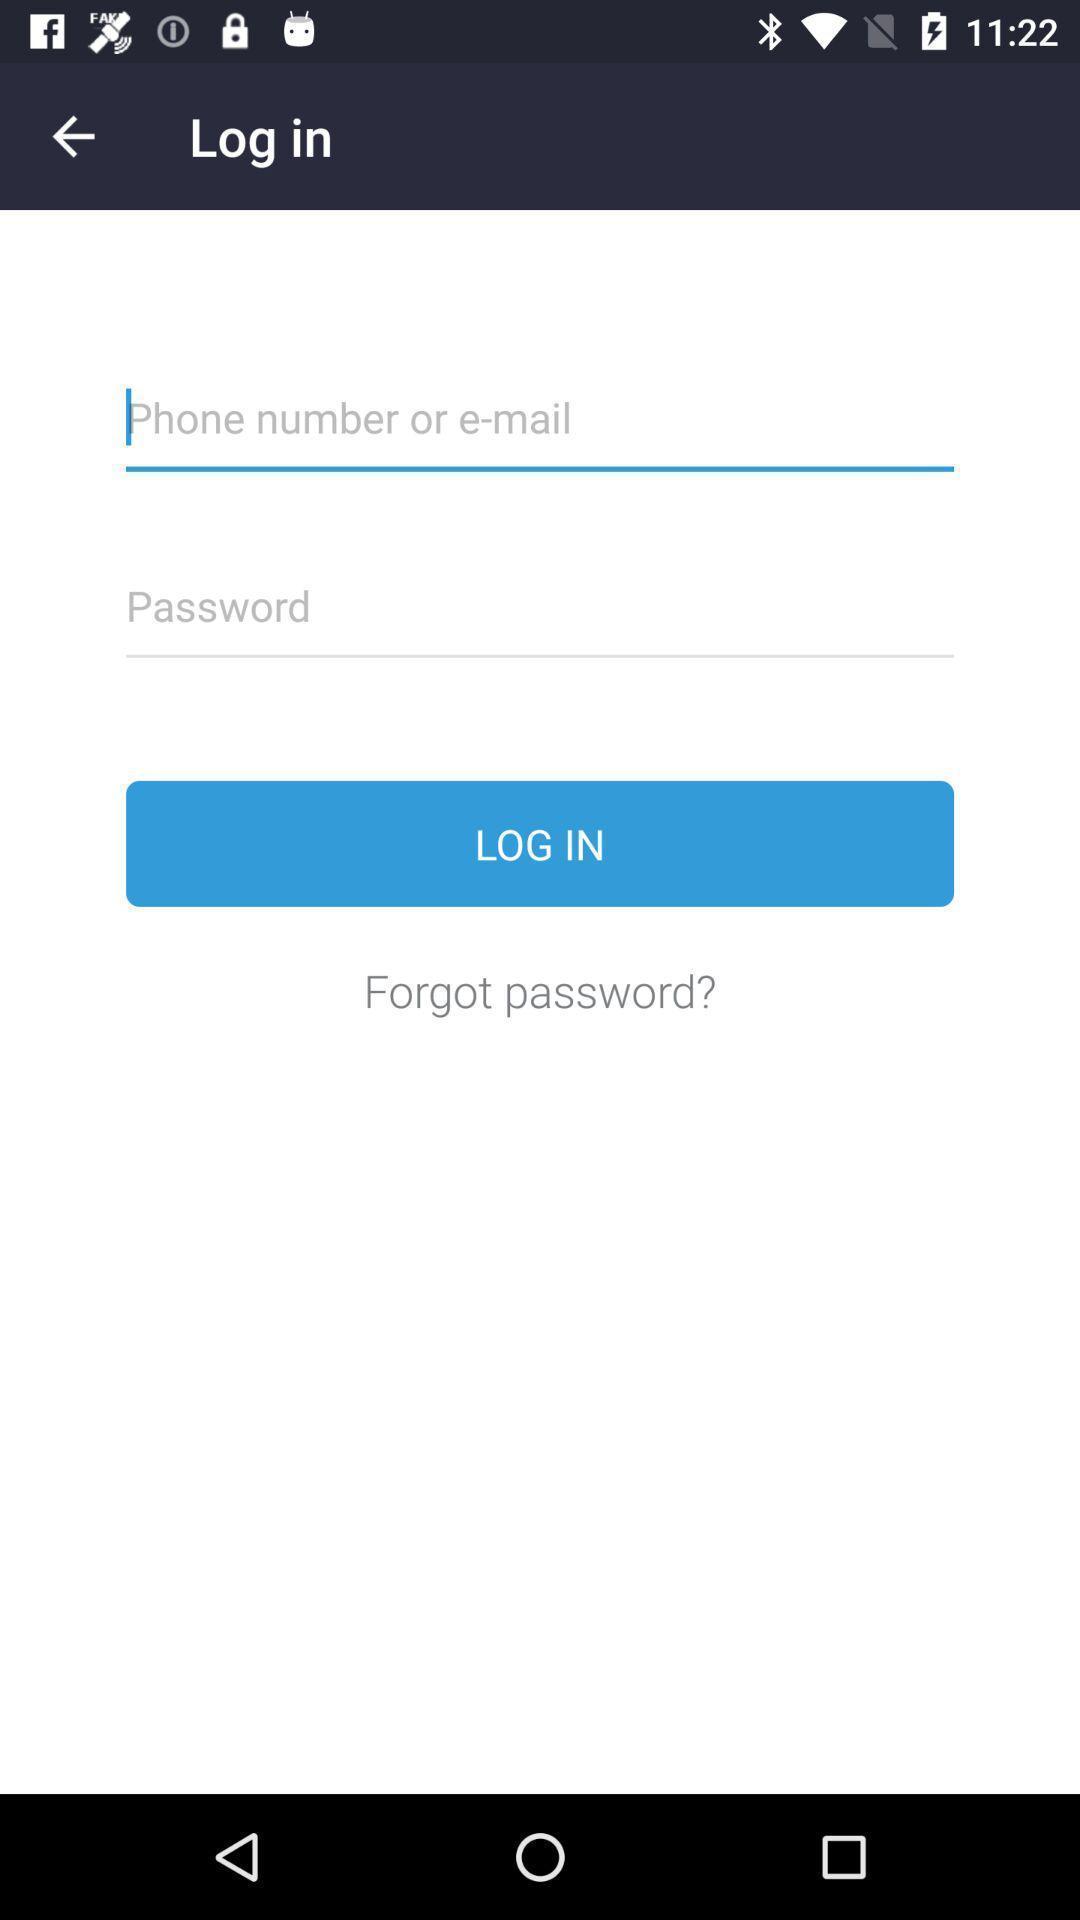Summarize the information in this screenshot. Login page. 